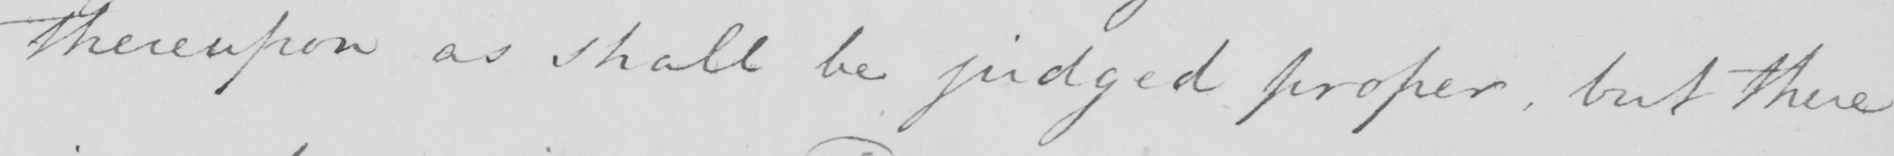What is written in this line of handwriting? thereupon as shall be judged proper , but there 